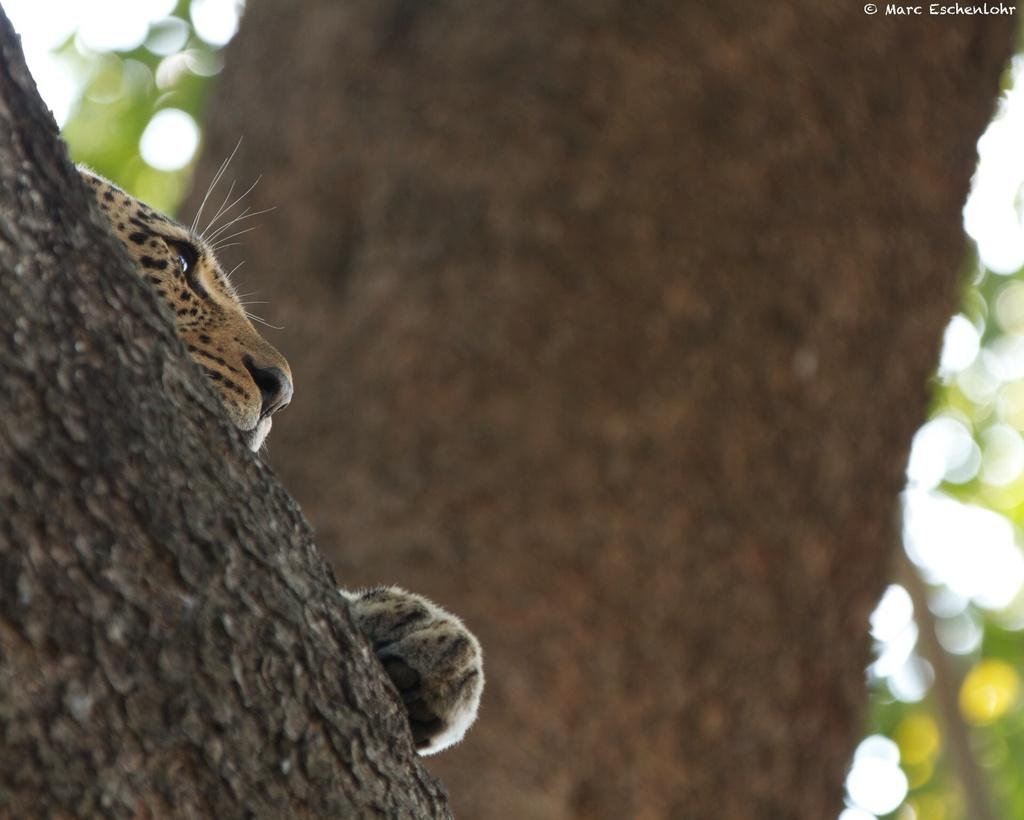What is located in the foreground of the image? There is a tree in the foreground of the image. What animal can be seen on the tree? A leopard is present on the tree. What else can be seen in the background of the image? There are additional trees visible in the background of the image. How does the leopard make a decision about which tree to climb in the image? There is no indication in the image of the leopard making a decision about which tree to climb, as it is already on the tree. What type of thrill can be experienced by the leopard while on the tree in the image? There is no indication of any thrill experienced by the leopard in the image. 